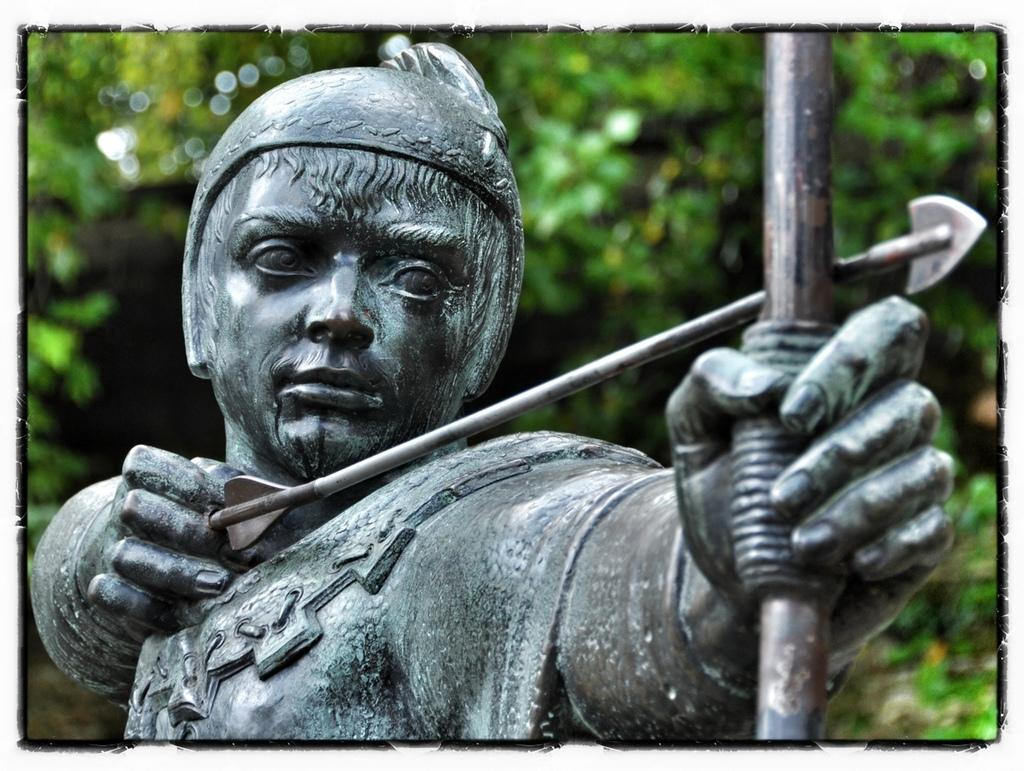What is the main subject of the image? There is a statue of a person in the image. What is the statue holding? The statue is holding a bow and arrow. Can you describe the background of the image? The background of the image is green and blurry. What type of bone can be seen in the image? There is no bone present in the image; it features a statue holding a bow and arrow. How does the goose feel about the statue in the image? There is no goose present in the image, so it is impossible to determine its feelings about the statue. 